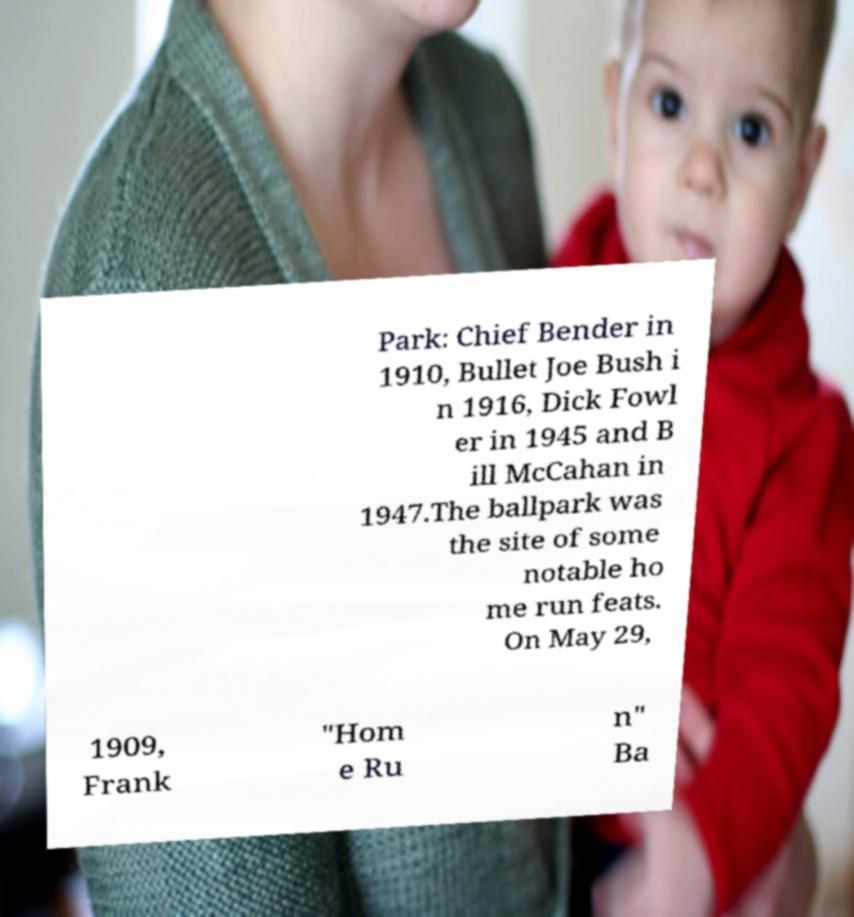For documentation purposes, I need the text within this image transcribed. Could you provide that? Park: Chief Bender in 1910, Bullet Joe Bush i n 1916, Dick Fowl er in 1945 and B ill McCahan in 1947.The ballpark was the site of some notable ho me run feats. On May 29, 1909, Frank "Hom e Ru n" Ba 